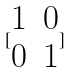Convert formula to latex. <formula><loc_0><loc_0><loc_500><loc_500>[ \begin{matrix} 1 & 0 \\ 0 & 1 \end{matrix} ]</formula> 